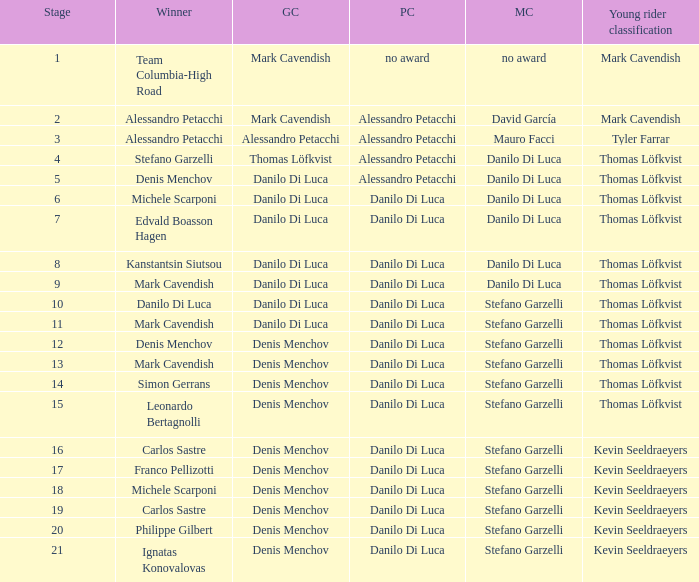When philippe gilbert is the winner who is the points classification? Danilo Di Luca. 